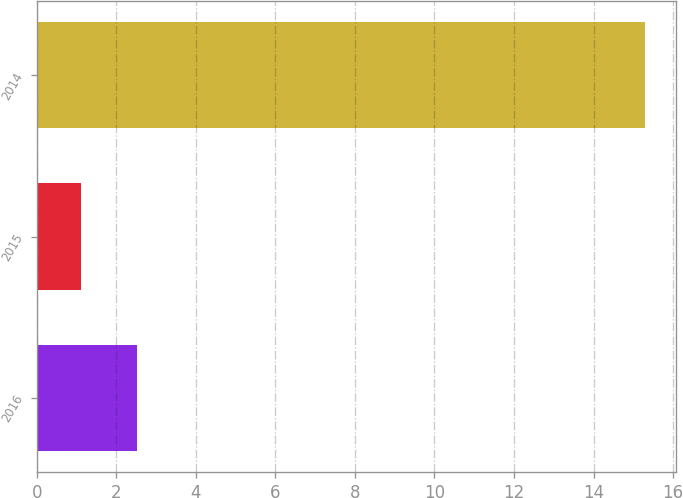Convert chart to OTSL. <chart><loc_0><loc_0><loc_500><loc_500><bar_chart><fcel>2016<fcel>2015<fcel>2014<nl><fcel>2.52<fcel>1.1<fcel>15.3<nl></chart> 